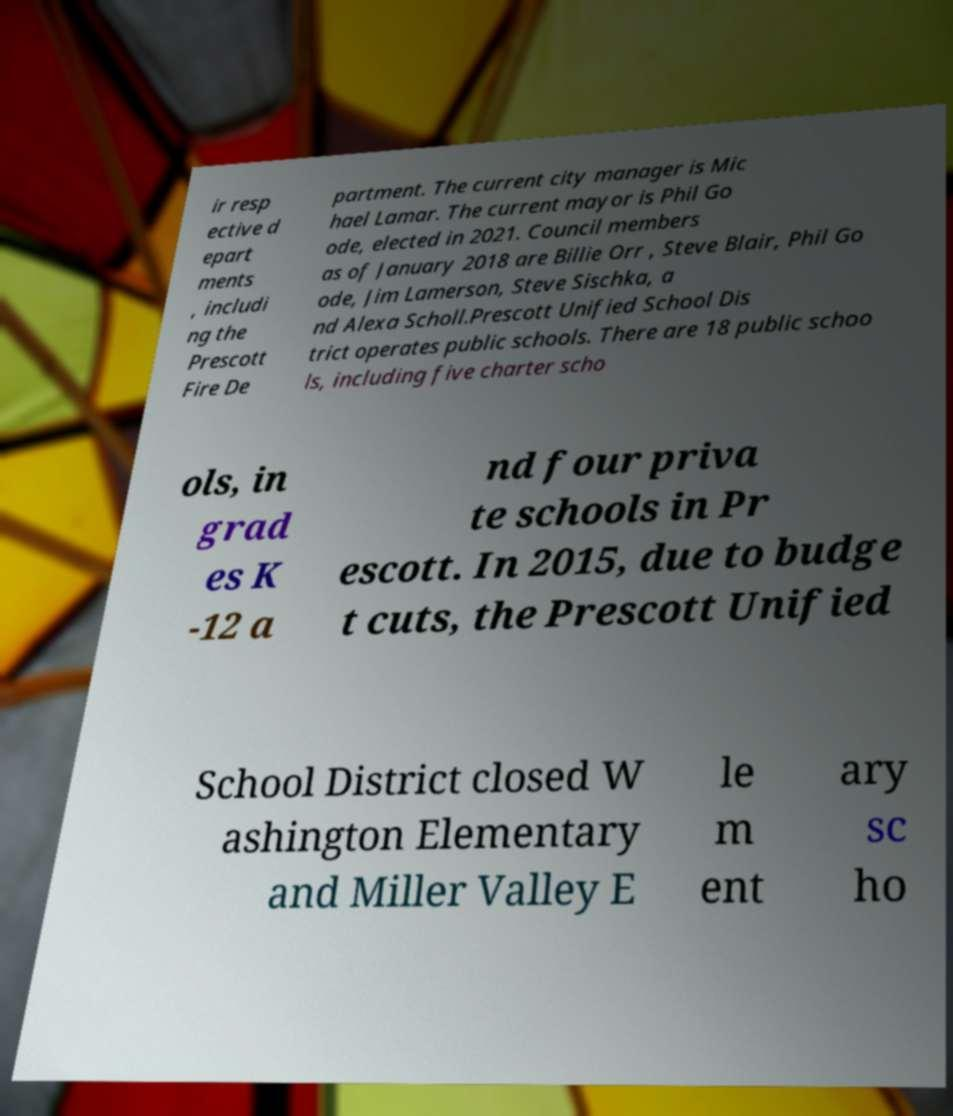Can you accurately transcribe the text from the provided image for me? ir resp ective d epart ments , includi ng the Prescott Fire De partment. The current city manager is Mic hael Lamar. The current mayor is Phil Go ode, elected in 2021. Council members as of January 2018 are Billie Orr , Steve Blair, Phil Go ode, Jim Lamerson, Steve Sischka, a nd Alexa Scholl.Prescott Unified School Dis trict operates public schools. There are 18 public schoo ls, including five charter scho ols, in grad es K -12 a nd four priva te schools in Pr escott. In 2015, due to budge t cuts, the Prescott Unified School District closed W ashington Elementary and Miller Valley E le m ent ary sc ho 